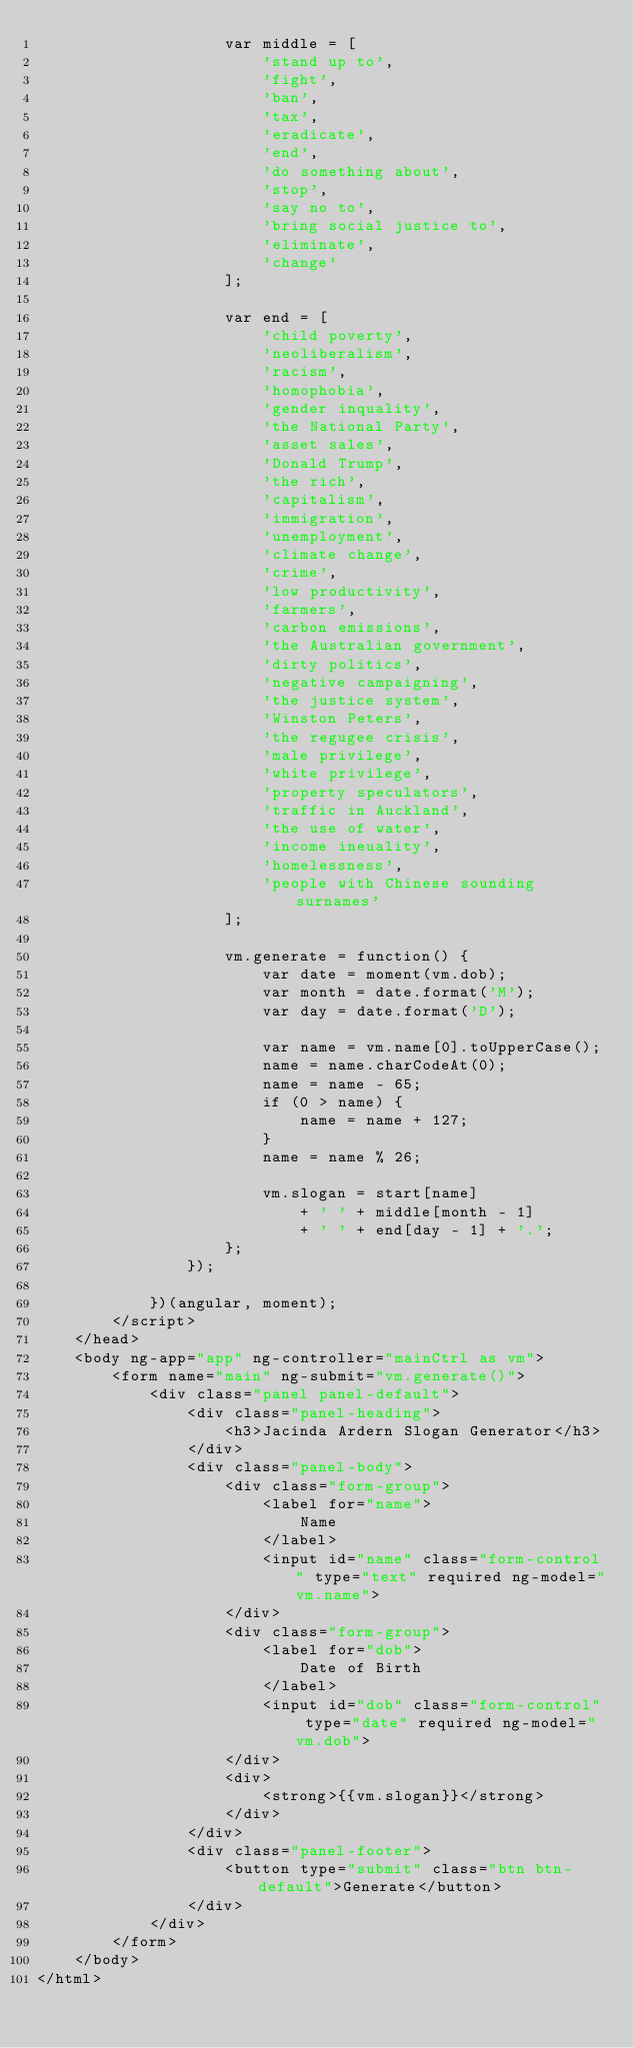Convert code to text. <code><loc_0><loc_0><loc_500><loc_500><_HTML_>					var middle = [
						'stand up to',
						'fight',
						'ban',
						'tax',
						'eradicate',
						'end',
						'do something about',
						'stop',
						'say no to',
						'bring social justice to',
						'eliminate',
						'change'
					];

					var end = [
						'child poverty',
						'neoliberalism',
						'racism',
						'homophobia',
						'gender inquality',
						'the National Party',
						'asset sales',
						'Donald Trump',
						'the rich',
						'capitalism',
						'immigration',
						'unemployment',
						'climate change',
						'crime',
						'low productivity',
						'farmers',
						'carbon emissions',
						'the Australian government',
						'dirty politics',
						'negative campaigning',
						'the justice system',
						'Winston Peters',
						'the regugee crisis',
						'male privilege',
						'white privilege',
						'property speculators',
						'traffic in Auckland',
						'the use of water',
						'income ineuality',
						'homelessness',
						'people with Chinese sounding surnames'
					];

					vm.generate = function() {
						var date = moment(vm.dob);
						var month = date.format('M');
						var day = date.format('D');

						var name = vm.name[0].toUpperCase();
						name = name.charCodeAt(0);
						name = name - 65;
						if (0 > name) {
							name = name + 127;
						}
						name = name % 26;

						vm.slogan = start[name]
							+ ' ' + middle[month - 1]
							+ ' ' + end[day - 1] + '.';
					};
				});

			})(angular, moment);
		</script>
	</head>
	<body ng-app="app" ng-controller="mainCtrl as vm">
		<form name="main" ng-submit="vm.generate()">
			<div class="panel panel-default">
				<div class="panel-heading">
					<h3>Jacinda Ardern Slogan Generator</h3>
				</div>
				<div class="panel-body">
					<div class="form-group">
						<label for="name">
							Name
						</label>
						<input id="name" class="form-control" type="text" required ng-model="vm.name">
					</div>
					<div class="form-group">
						<label for="dob">
							Date of Birth
						</label>
						<input id="dob" class="form-control" type="date" required ng-model="vm.dob">
					</div>
					<div>
						<strong>{{vm.slogan}}</strong>
					</div>
				</div>
				<div class="panel-footer">
					<button type="submit" class="btn btn-default">Generate</button>
				</div>
			</div>
		</form>
	</body>
</html>
</code> 